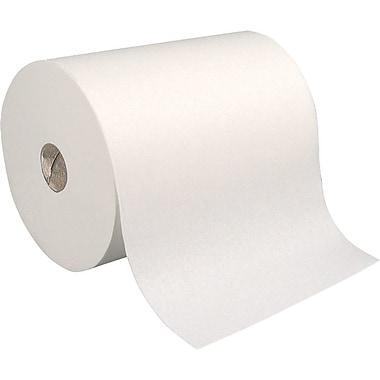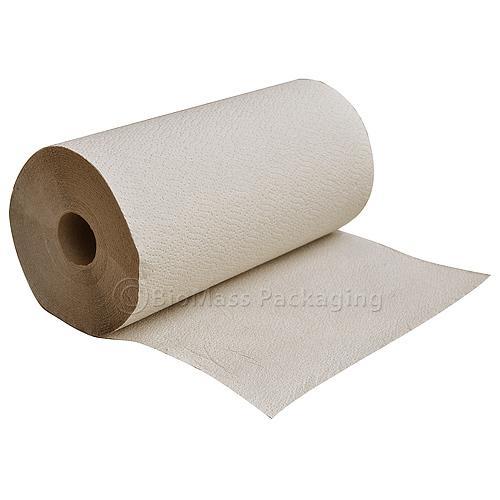The first image is the image on the left, the second image is the image on the right. Considering the images on both sides, is "All these images contain paper towels standing upright on their rolls." valid? Answer yes or no. No. 